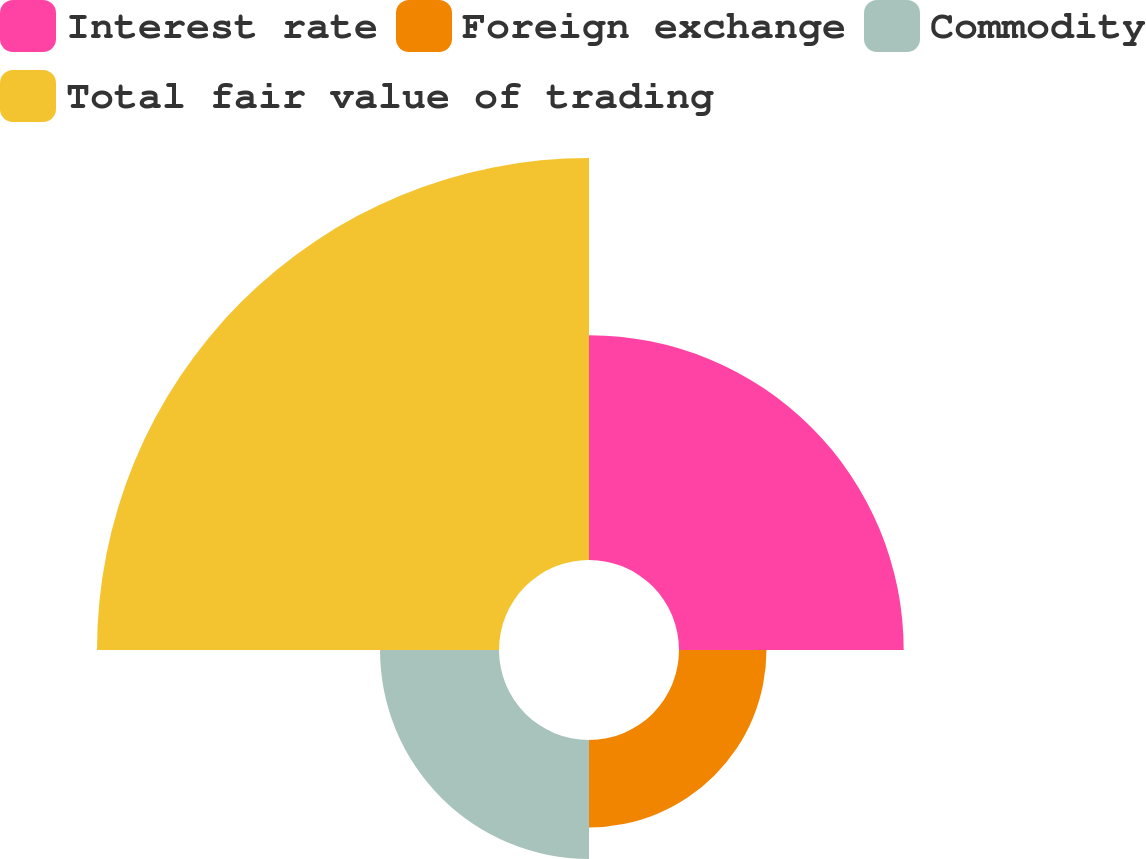<chart> <loc_0><loc_0><loc_500><loc_500><pie_chart><fcel>Interest rate<fcel>Foreign exchange<fcel>Commodity<fcel>Total fair value of trading<nl><fcel>26.97%<fcel>10.5%<fcel>14.28%<fcel>48.25%<nl></chart> 